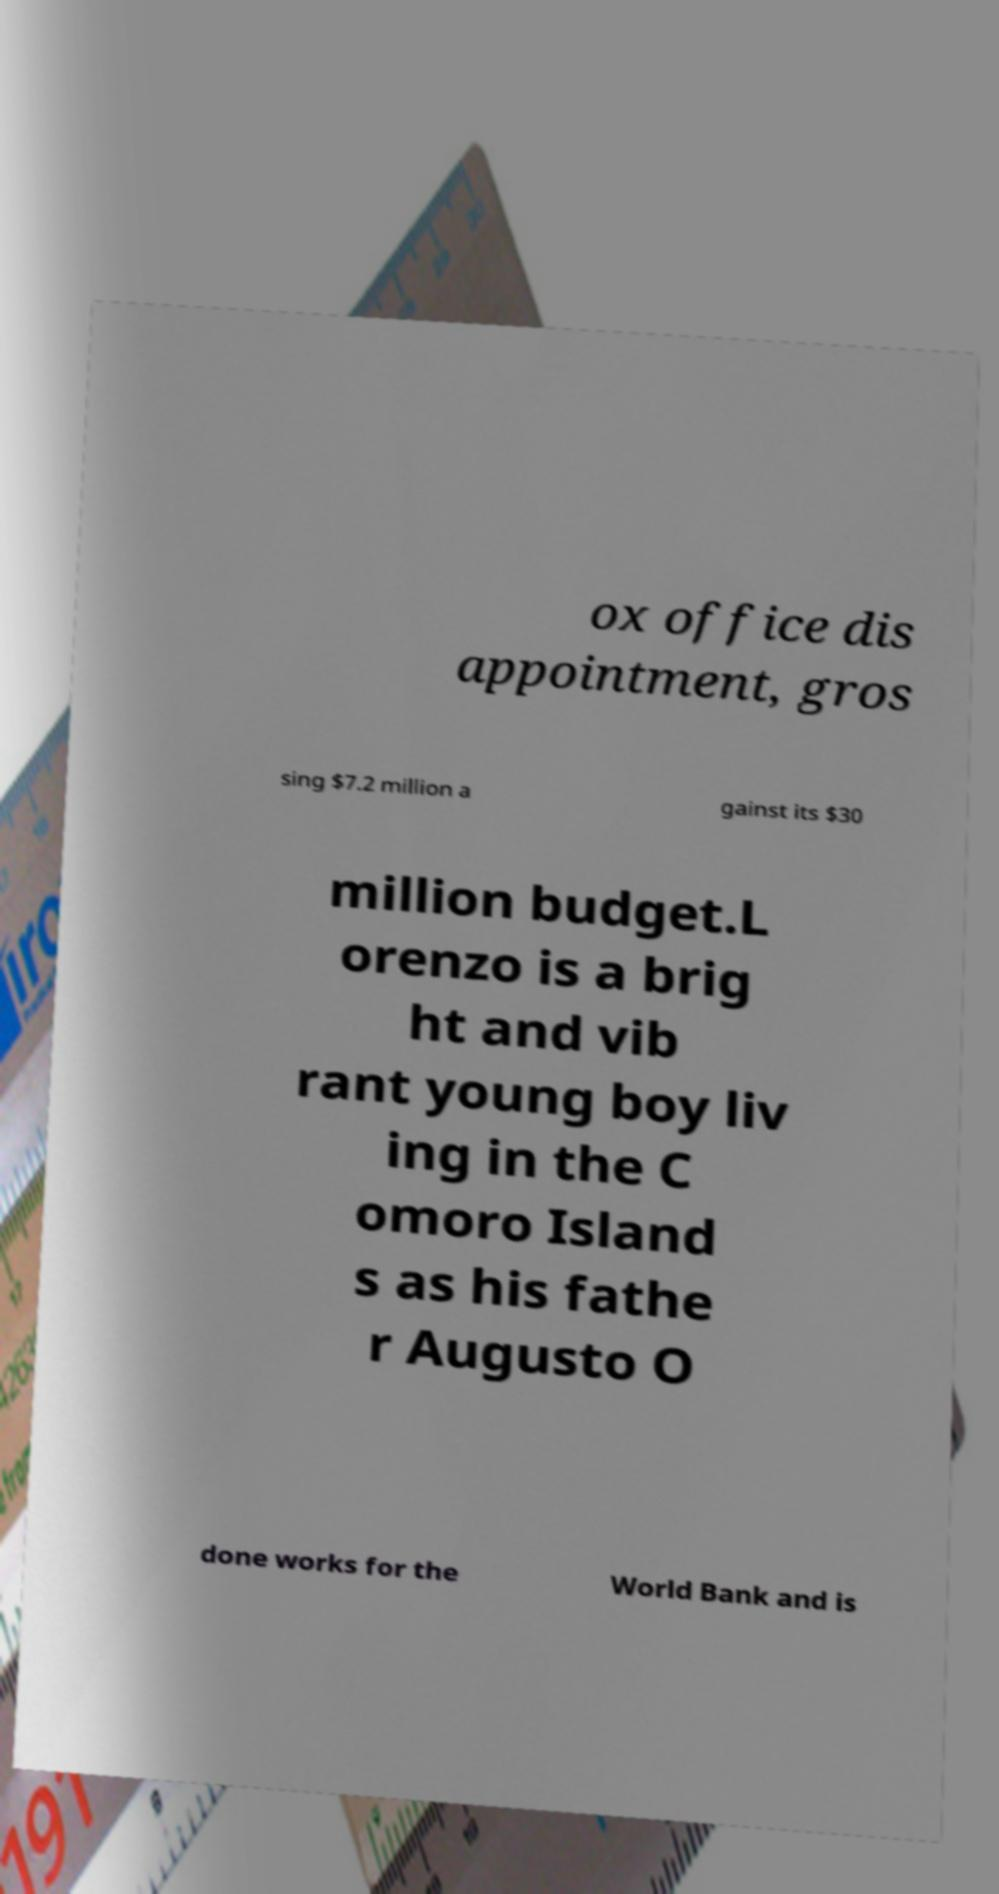I need the written content from this picture converted into text. Can you do that? ox office dis appointment, gros sing $7.2 million a gainst its $30 million budget.L orenzo is a brig ht and vib rant young boy liv ing in the C omoro Island s as his fathe r Augusto O done works for the World Bank and is 